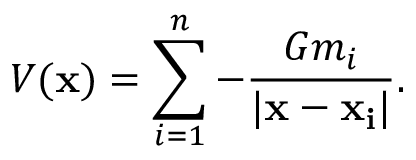<formula> <loc_0><loc_0><loc_500><loc_500>V ( x ) = \sum _ { i = 1 } ^ { n } - { \frac { G m _ { i } } { | x - x _ { i } | } } .</formula> 